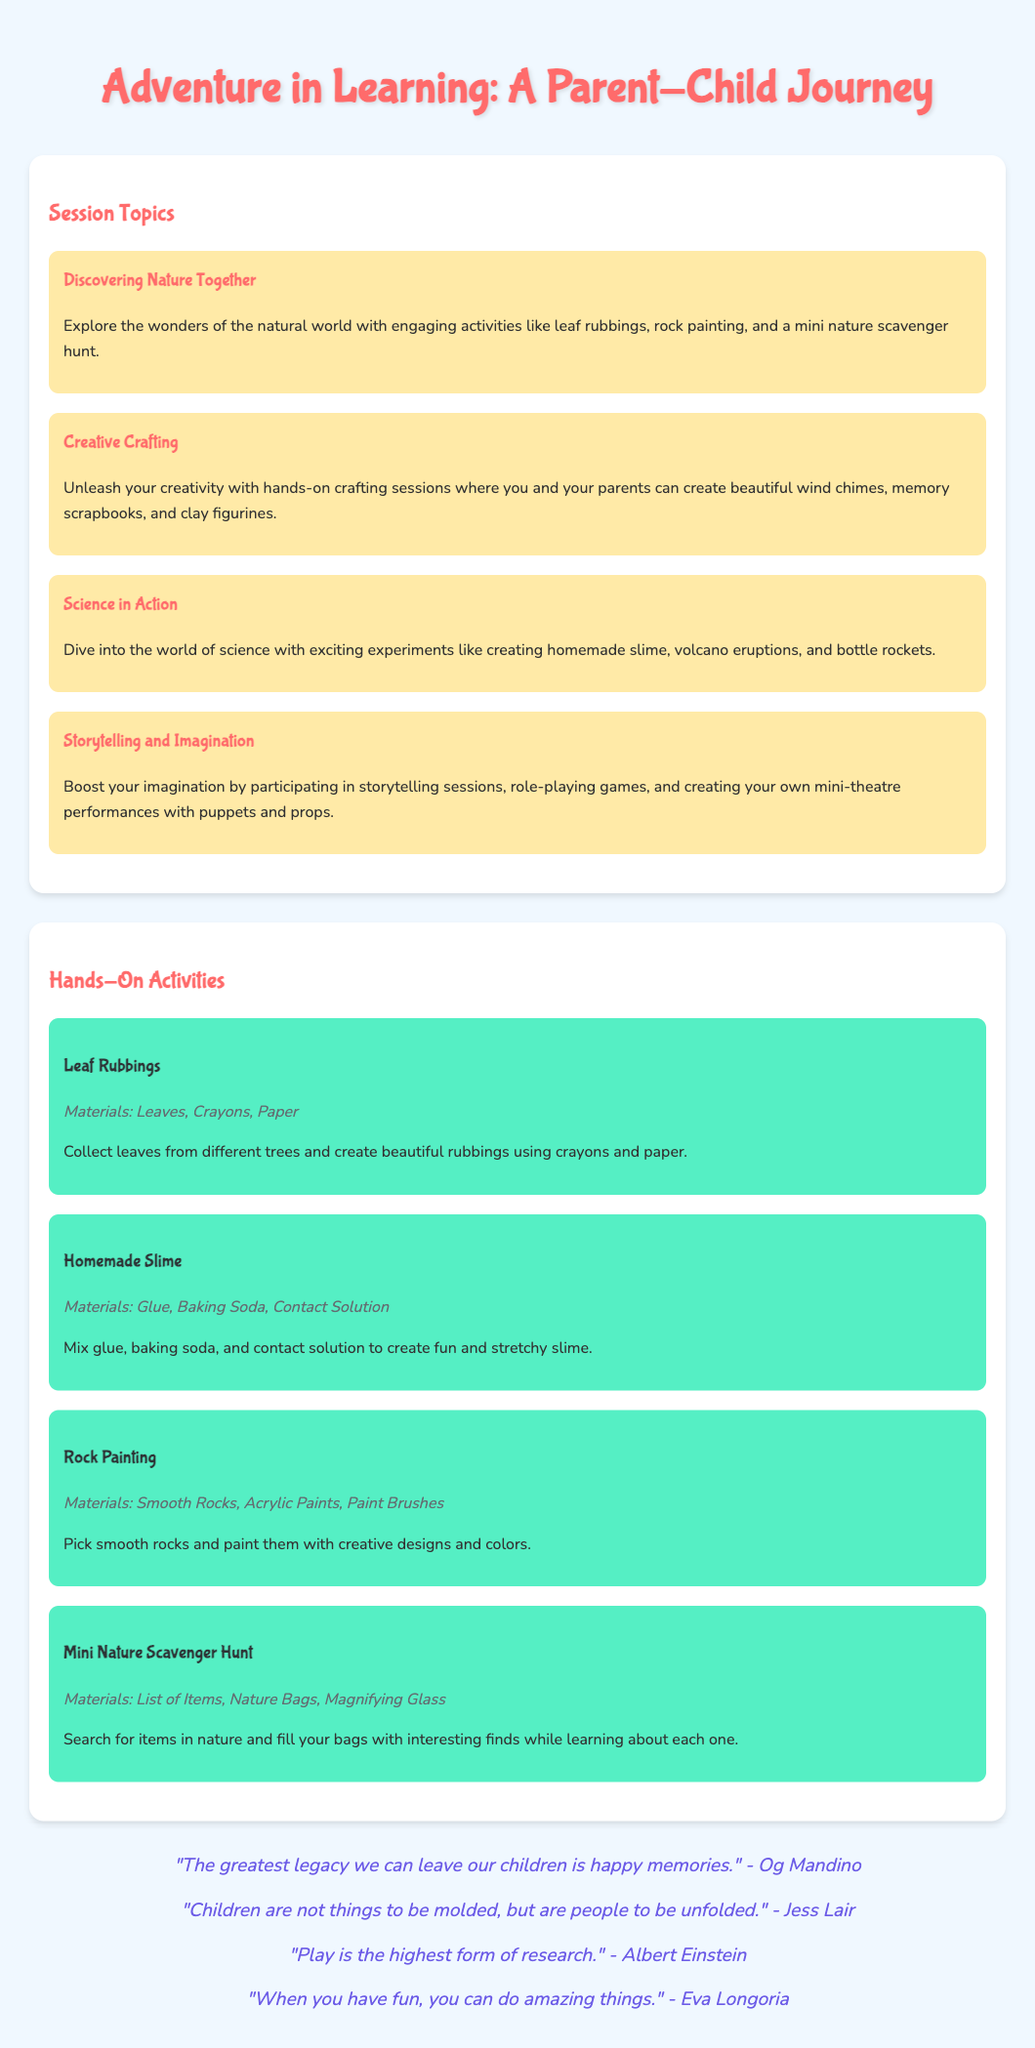What is the title of the workshop? The title of the workshop is presented at the top of the document.
Answer: Adventure in Learning: A Parent-Child Journey How many session topics are there? The number of session topics can be counted in the section titled "Session Topics."
Answer: 4 What is one of the hands-on activities mentioned? This question asks for specific activities listed in the "Hands-On Activities" section.
Answer: Homemade Slime What materials are needed for leaf rubbings? The materials needed are specified in the description of the activity "Leaf Rubbings."
Answer: Leaves, Crayons, Paper Which quote is attributed to Albert Einstein? This question is about the quotes section, specifically looking for a quote by Albert Einstein.
Answer: "Play is the highest form of research." What type of activity is "Mini Nature Scavenger Hunt"? This question requires understanding the type of activity listed under "Hands-On Activities."
Answer: Activity What quote emphasizes the importance of fun? This question looks for a specific quote that talks about having fun.
Answer: "When you have fun, you can do amazing things." What is the focus of the "Creative Crafting" session? This question looks for a summary of what the "Creative Crafting" session entails.
Answer: Hands-on crafting How does the workshop encourage parent-child interaction? This question requires reasoning about how activities promote interaction based on session topics.
Answer: Through hands-on activities 